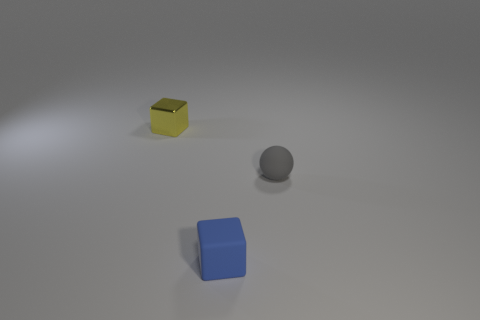How many things are tiny blocks that are behind the gray matte thing or green metal objects?
Offer a very short reply. 1. What shape is the object that is the same material as the blue block?
Provide a short and direct response. Sphere. Is there any other thing that is the same shape as the small blue rubber object?
Make the answer very short. Yes. What color is the object that is both to the right of the yellow block and behind the tiny matte cube?
Your response must be concise. Gray. How many cylinders are either tiny brown things or tiny metal things?
Your answer should be compact. 0. How many gray matte balls are the same size as the yellow metallic object?
Give a very brief answer. 1. There is a tiny shiny cube that is behind the tiny gray ball; what number of tiny objects are behind it?
Your answer should be very brief. 0. What size is the thing that is both behind the tiny blue block and to the left of the small matte sphere?
Offer a terse response. Small. Are there more gray balls than big cyan blocks?
Give a very brief answer. Yes. Is there a metallic block that has the same color as the rubber block?
Your answer should be very brief. No. 